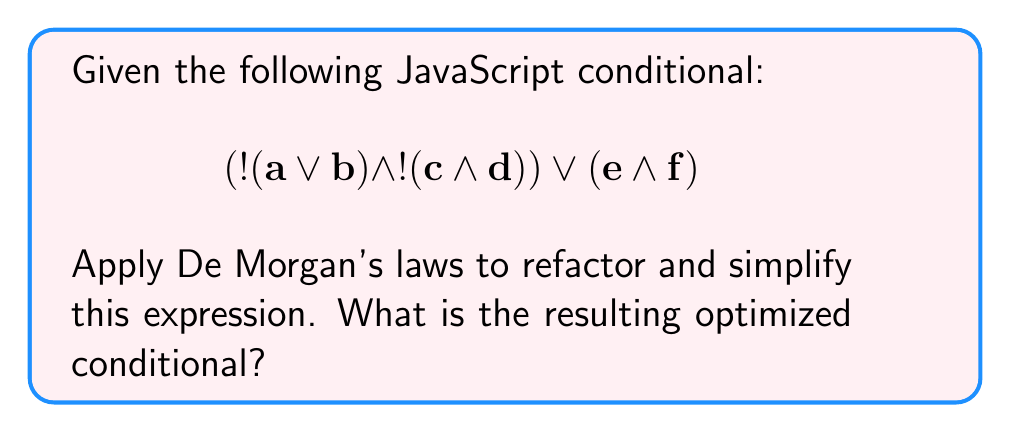Provide a solution to this math problem. Let's apply De Morgan's laws step by step to simplify the given expression:

1. First, let's focus on the left part of the expression: $!(a || b) && !(c && d)$

2. Apply De Morgan's law to $!(a || b)$:
   $!(a || b) = !a && !b$

3. Apply De Morgan's law to $!(c && d)$:
   $!(c && d) = !c || !d$

4. Now our expression looks like this:
   $(((!a && !b) && (!c || !d)) || (e && f))$

5. Let's distribute the AND operation over the OR in $(!c || !d)$:
   $((!a && !b && !c) || (!a && !b && !d)) || (e && f)$

6. Now we have the expression in its simplest form using De Morgan's laws:
   $((!a && !b && !c) || (!a && !b && !d) || (e && f))$

This refactored expression is equivalent to the original but uses simpler logical operations, which can potentially improve the efficiency of the code.
Answer: $((!a && !b && !c) || (!a && !b && !d) || (e && f))$ 